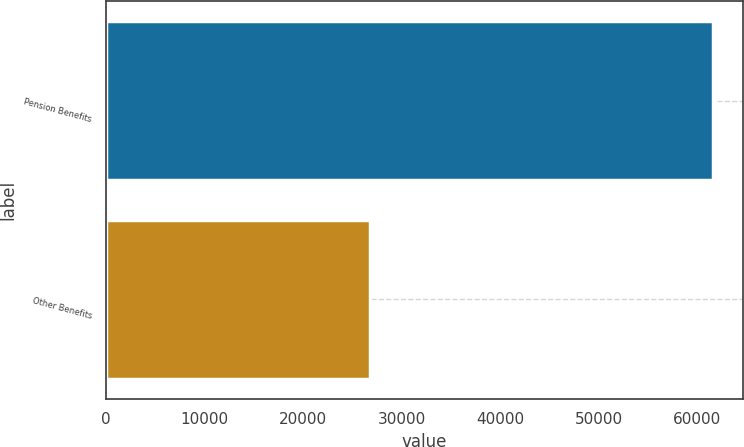Convert chart. <chart><loc_0><loc_0><loc_500><loc_500><bar_chart><fcel>Pension Benefits<fcel>Other Benefits<nl><fcel>61591<fcel>26782<nl></chart> 